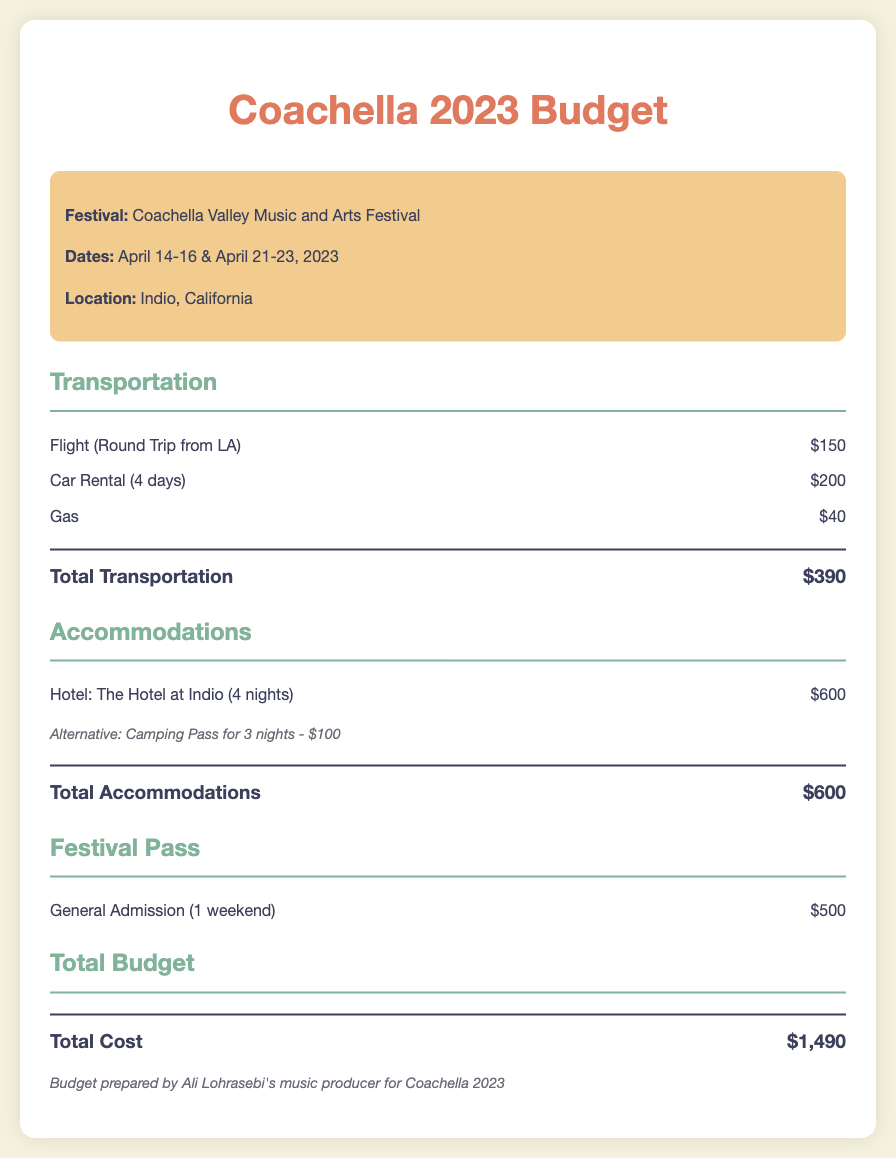What is the total cost of transportation? The total transportation cost is calculated based on the flight, car rental, and gas expenses listed in the document, adding up to $150 + $200 + $40.
Answer: $390 How many nights is the hotel accommodation? The document specifies the hotel stay as lasting for 4 nights, providing details on the cost for those nights.
Answer: 4 nights What is the cost of the camping pass? The document presents an alternative accommodation option, indicating that the camping pass for 3 nights costs a total of $100.
Answer: $100 What is the price of the general admission festival pass? The document lists the cost for a general admission festival pass for one weekend, which is specifically stated as $500.
Answer: $500 What are the dates of the Coachella festival? The festival dates are specifically mentioned in the document as April 14-16 and April 21-23, 2023.
Answer: April 14-16 & April 21-23, 2023 What is the total budget listed in the document? The total budget is the summation of transportation, accommodation, and festival pass costs, leading to a total of $1,490 stated at the end.
Answer: $1,490 What is the location of the Coachella festival? The location of the festival is highlighted in the document, detailing that it takes place in Indio, California.
Answer: Indio, California How much is the car rental for 4 days? The document indicates the cost for renting a car for 4 days is listed as $200.
Answer: $200 What does the budget note specify? The note in the budget specifies that it was prepared by Ali Lohrasebi's music producer for the Coachella 2023 event.
Answer: Prepared by Ali Lohrasebi's music producer for Coachella 2023 